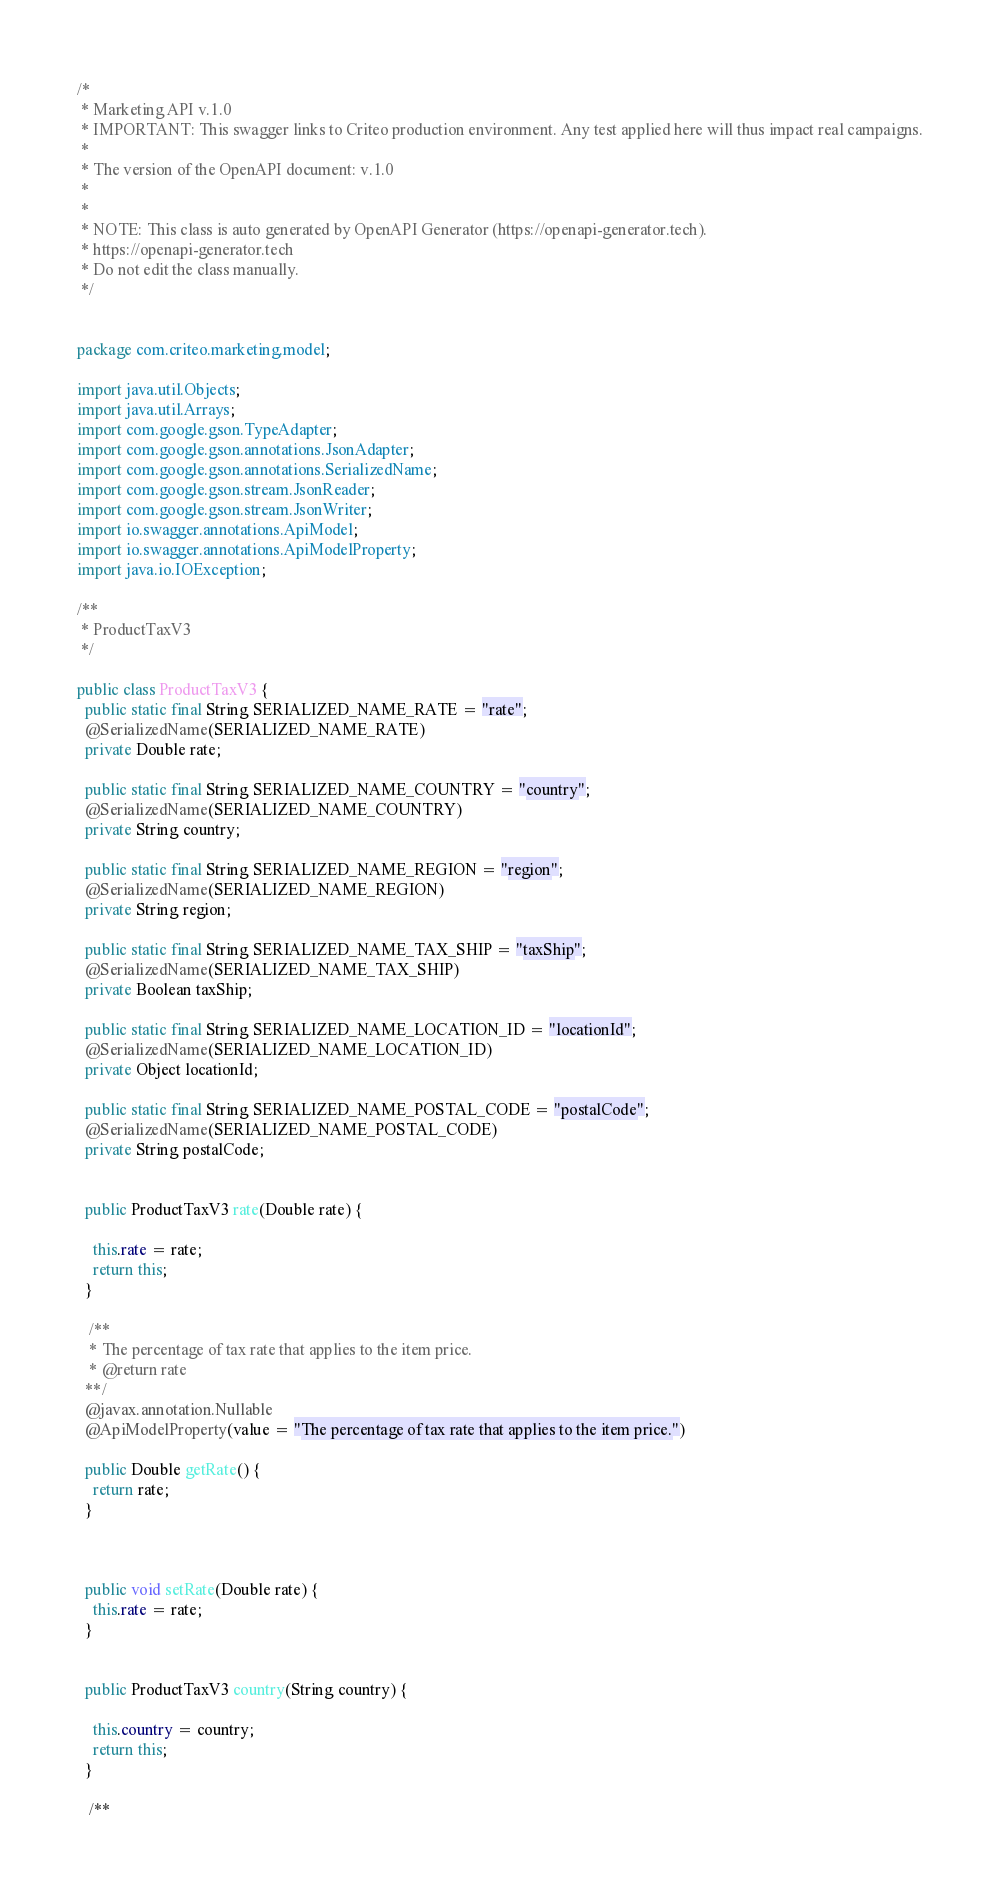<code> <loc_0><loc_0><loc_500><loc_500><_Java_>/*
 * Marketing API v.1.0
 * IMPORTANT: This swagger links to Criteo production environment. Any test applied here will thus impact real campaigns.
 *
 * The version of the OpenAPI document: v.1.0
 * 
 *
 * NOTE: This class is auto generated by OpenAPI Generator (https://openapi-generator.tech).
 * https://openapi-generator.tech
 * Do not edit the class manually.
 */


package com.criteo.marketing.model;

import java.util.Objects;
import java.util.Arrays;
import com.google.gson.TypeAdapter;
import com.google.gson.annotations.JsonAdapter;
import com.google.gson.annotations.SerializedName;
import com.google.gson.stream.JsonReader;
import com.google.gson.stream.JsonWriter;
import io.swagger.annotations.ApiModel;
import io.swagger.annotations.ApiModelProperty;
import java.io.IOException;

/**
 * ProductTaxV3
 */

public class ProductTaxV3 {
  public static final String SERIALIZED_NAME_RATE = "rate";
  @SerializedName(SERIALIZED_NAME_RATE)
  private Double rate;

  public static final String SERIALIZED_NAME_COUNTRY = "country";
  @SerializedName(SERIALIZED_NAME_COUNTRY)
  private String country;

  public static final String SERIALIZED_NAME_REGION = "region";
  @SerializedName(SERIALIZED_NAME_REGION)
  private String region;

  public static final String SERIALIZED_NAME_TAX_SHIP = "taxShip";
  @SerializedName(SERIALIZED_NAME_TAX_SHIP)
  private Boolean taxShip;

  public static final String SERIALIZED_NAME_LOCATION_ID = "locationId";
  @SerializedName(SERIALIZED_NAME_LOCATION_ID)
  private Object locationId;

  public static final String SERIALIZED_NAME_POSTAL_CODE = "postalCode";
  @SerializedName(SERIALIZED_NAME_POSTAL_CODE)
  private String postalCode;


  public ProductTaxV3 rate(Double rate) {
    
    this.rate = rate;
    return this;
  }

   /**
   * The percentage of tax rate that applies to the item price.
   * @return rate
  **/
  @javax.annotation.Nullable
  @ApiModelProperty(value = "The percentage of tax rate that applies to the item price.")

  public Double getRate() {
    return rate;
  }



  public void setRate(Double rate) {
    this.rate = rate;
  }


  public ProductTaxV3 country(String country) {
    
    this.country = country;
    return this;
  }

   /**</code> 